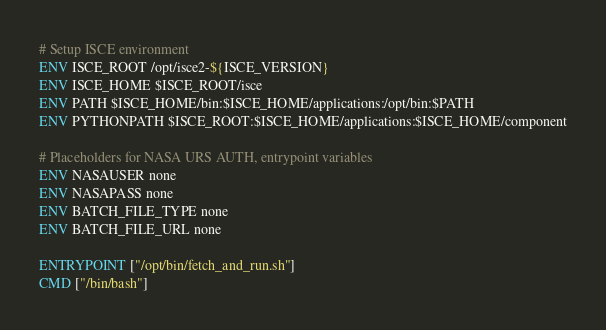<code> <loc_0><loc_0><loc_500><loc_500><_Dockerfile_># Setup ISCE environment
ENV ISCE_ROOT /opt/isce2-${ISCE_VERSION}
ENV ISCE_HOME $ISCE_ROOT/isce
ENV PATH $ISCE_HOME/bin:$ISCE_HOME/applications:/opt/bin:$PATH
ENV PYTHONPATH $ISCE_ROOT:$ISCE_HOME/applications:$ISCE_HOME/component

# Placeholders for NASA URS AUTH, entrypoint variables
ENV NASAUSER none
ENV NASAPASS none
ENV BATCH_FILE_TYPE none
ENV BATCH_FILE_URL none

ENTRYPOINT ["/opt/bin/fetch_and_run.sh"]
CMD ["/bin/bash"]
</code> 